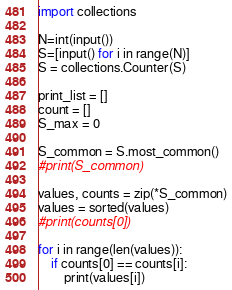<code> <loc_0><loc_0><loc_500><loc_500><_Python_>import collections

N=int(input())
S=[input() for i in range(N)]
S = collections.Counter(S)

print_list = []
count = []
S_max = 0

S_common = S.most_common()
#print(S_common)

values, counts = zip(*S_common)
values = sorted(values)
#print(counts[0])

for i in range(len(values)):
	if counts[0] == counts[i]:
		print(values[i])
</code> 